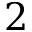Convert formula to latex. <formula><loc_0><loc_0><loc_500><loc_500>2</formula> 